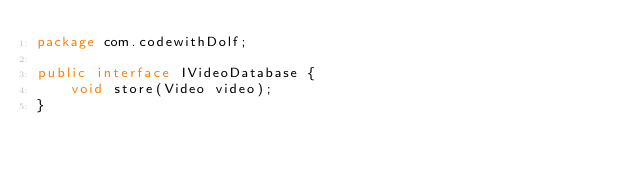<code> <loc_0><loc_0><loc_500><loc_500><_Java_>package com.codewithDolf;

public interface IVideoDatabase {
    void store(Video video);
}
</code> 